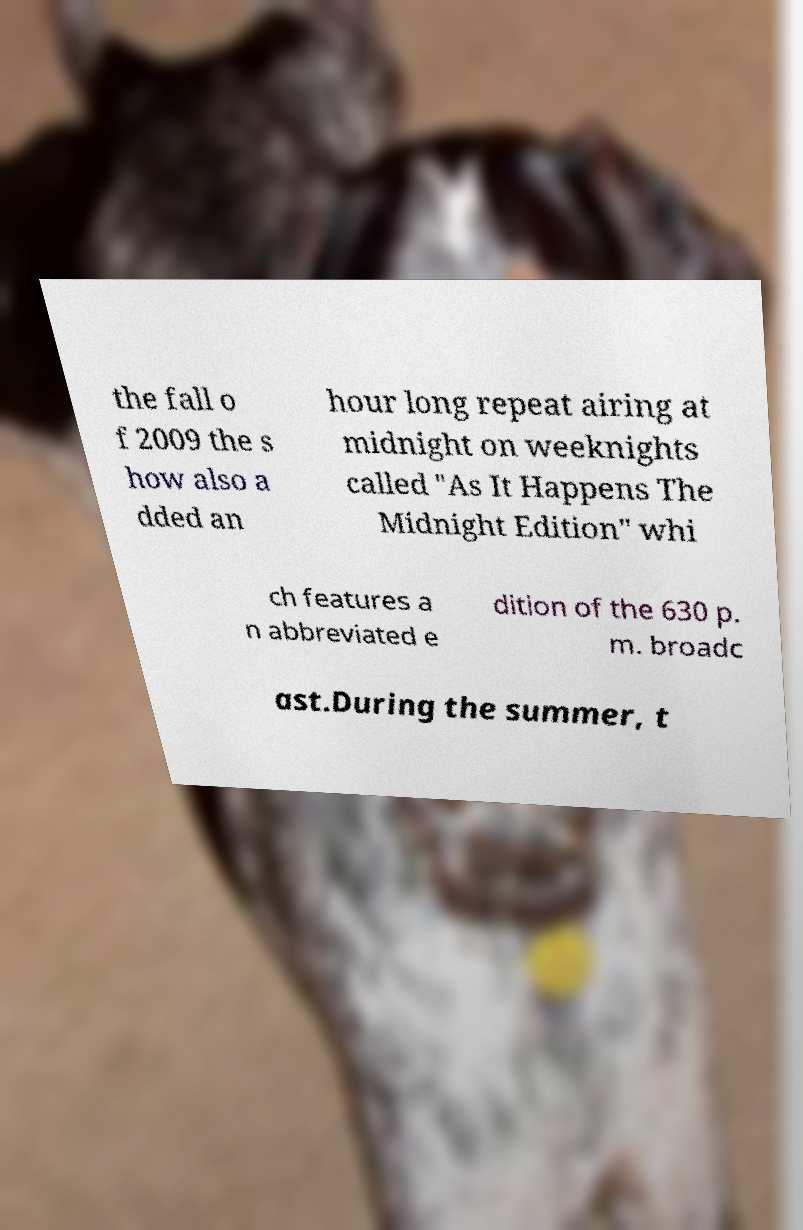For documentation purposes, I need the text within this image transcribed. Could you provide that? the fall o f 2009 the s how also a dded an hour long repeat airing at midnight on weeknights called "As It Happens The Midnight Edition" whi ch features a n abbreviated e dition of the 630 p. m. broadc ast.During the summer, t 